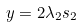Convert formula to latex. <formula><loc_0><loc_0><loc_500><loc_500>y & = 2 \lambda _ { 2 } s _ { 2 }</formula> 